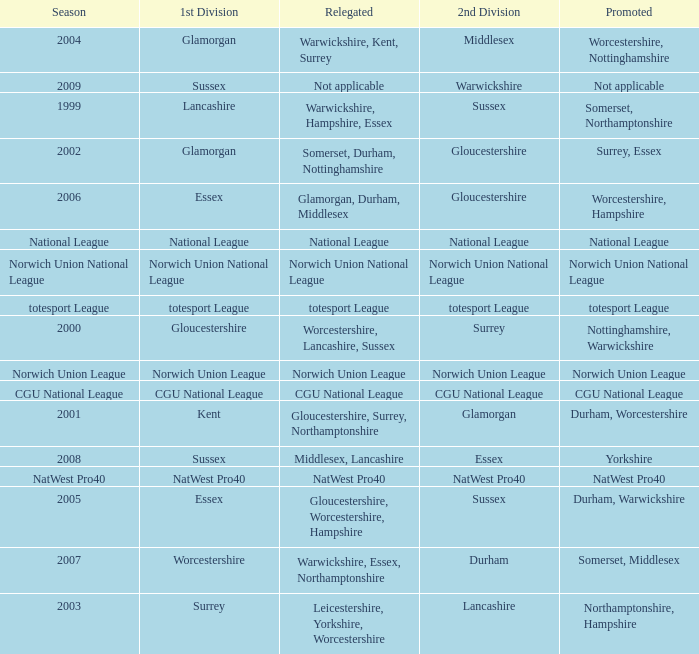What was relegated in the 2nd division of middlesex? Warwickshire, Kent, Surrey. 